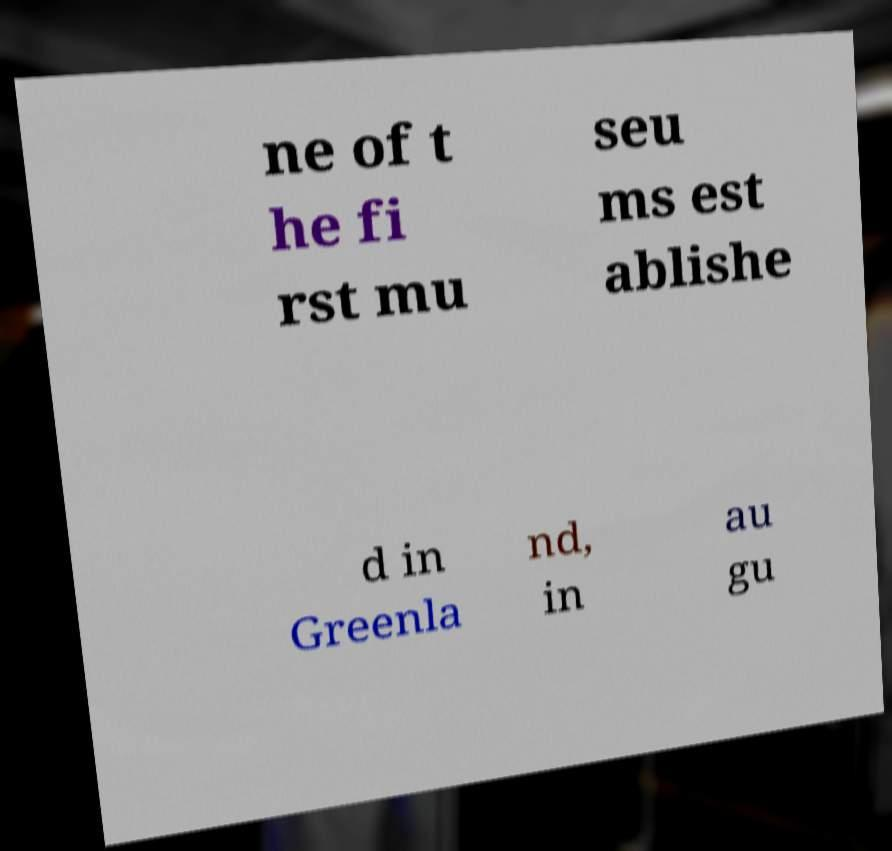There's text embedded in this image that I need extracted. Can you transcribe it verbatim? ne of t he fi rst mu seu ms est ablishe d in Greenla nd, in au gu 